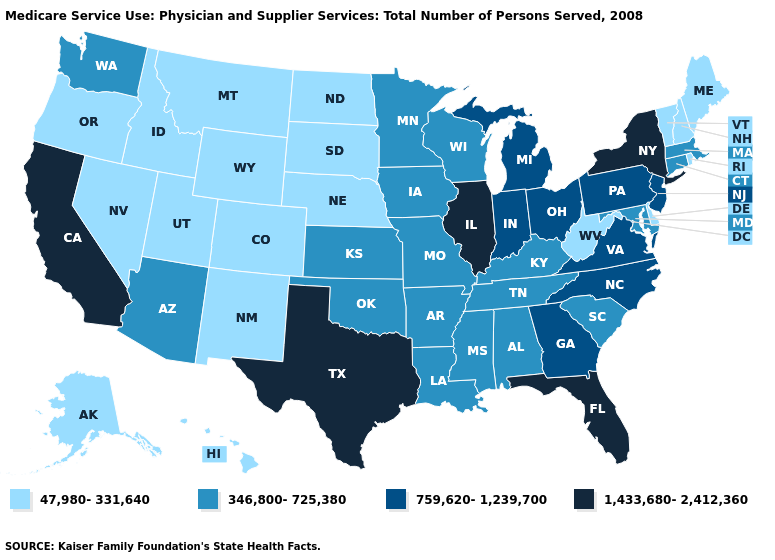Does New Jersey have a lower value than Minnesota?
Be succinct. No. Does the map have missing data?
Quick response, please. No. What is the value of New Jersey?
Concise answer only. 759,620-1,239,700. Name the states that have a value in the range 759,620-1,239,700?
Answer briefly. Georgia, Indiana, Michigan, New Jersey, North Carolina, Ohio, Pennsylvania, Virginia. Does New Hampshire have a lower value than Rhode Island?
Give a very brief answer. No. Is the legend a continuous bar?
Keep it brief. No. Name the states that have a value in the range 1,433,680-2,412,360?
Be succinct. California, Florida, Illinois, New York, Texas. Does Nevada have the lowest value in the USA?
Short answer required. Yes. Name the states that have a value in the range 47,980-331,640?
Write a very short answer. Alaska, Colorado, Delaware, Hawaii, Idaho, Maine, Montana, Nebraska, Nevada, New Hampshire, New Mexico, North Dakota, Oregon, Rhode Island, South Dakota, Utah, Vermont, West Virginia, Wyoming. Name the states that have a value in the range 346,800-725,380?
Give a very brief answer. Alabama, Arizona, Arkansas, Connecticut, Iowa, Kansas, Kentucky, Louisiana, Maryland, Massachusetts, Minnesota, Mississippi, Missouri, Oklahoma, South Carolina, Tennessee, Washington, Wisconsin. What is the value of Arkansas?
Give a very brief answer. 346,800-725,380. Among the states that border Missouri , does Illinois have the highest value?
Short answer required. Yes. Among the states that border Oregon , which have the lowest value?
Short answer required. Idaho, Nevada. Does the map have missing data?
Answer briefly. No. What is the highest value in the MidWest ?
Answer briefly. 1,433,680-2,412,360. 